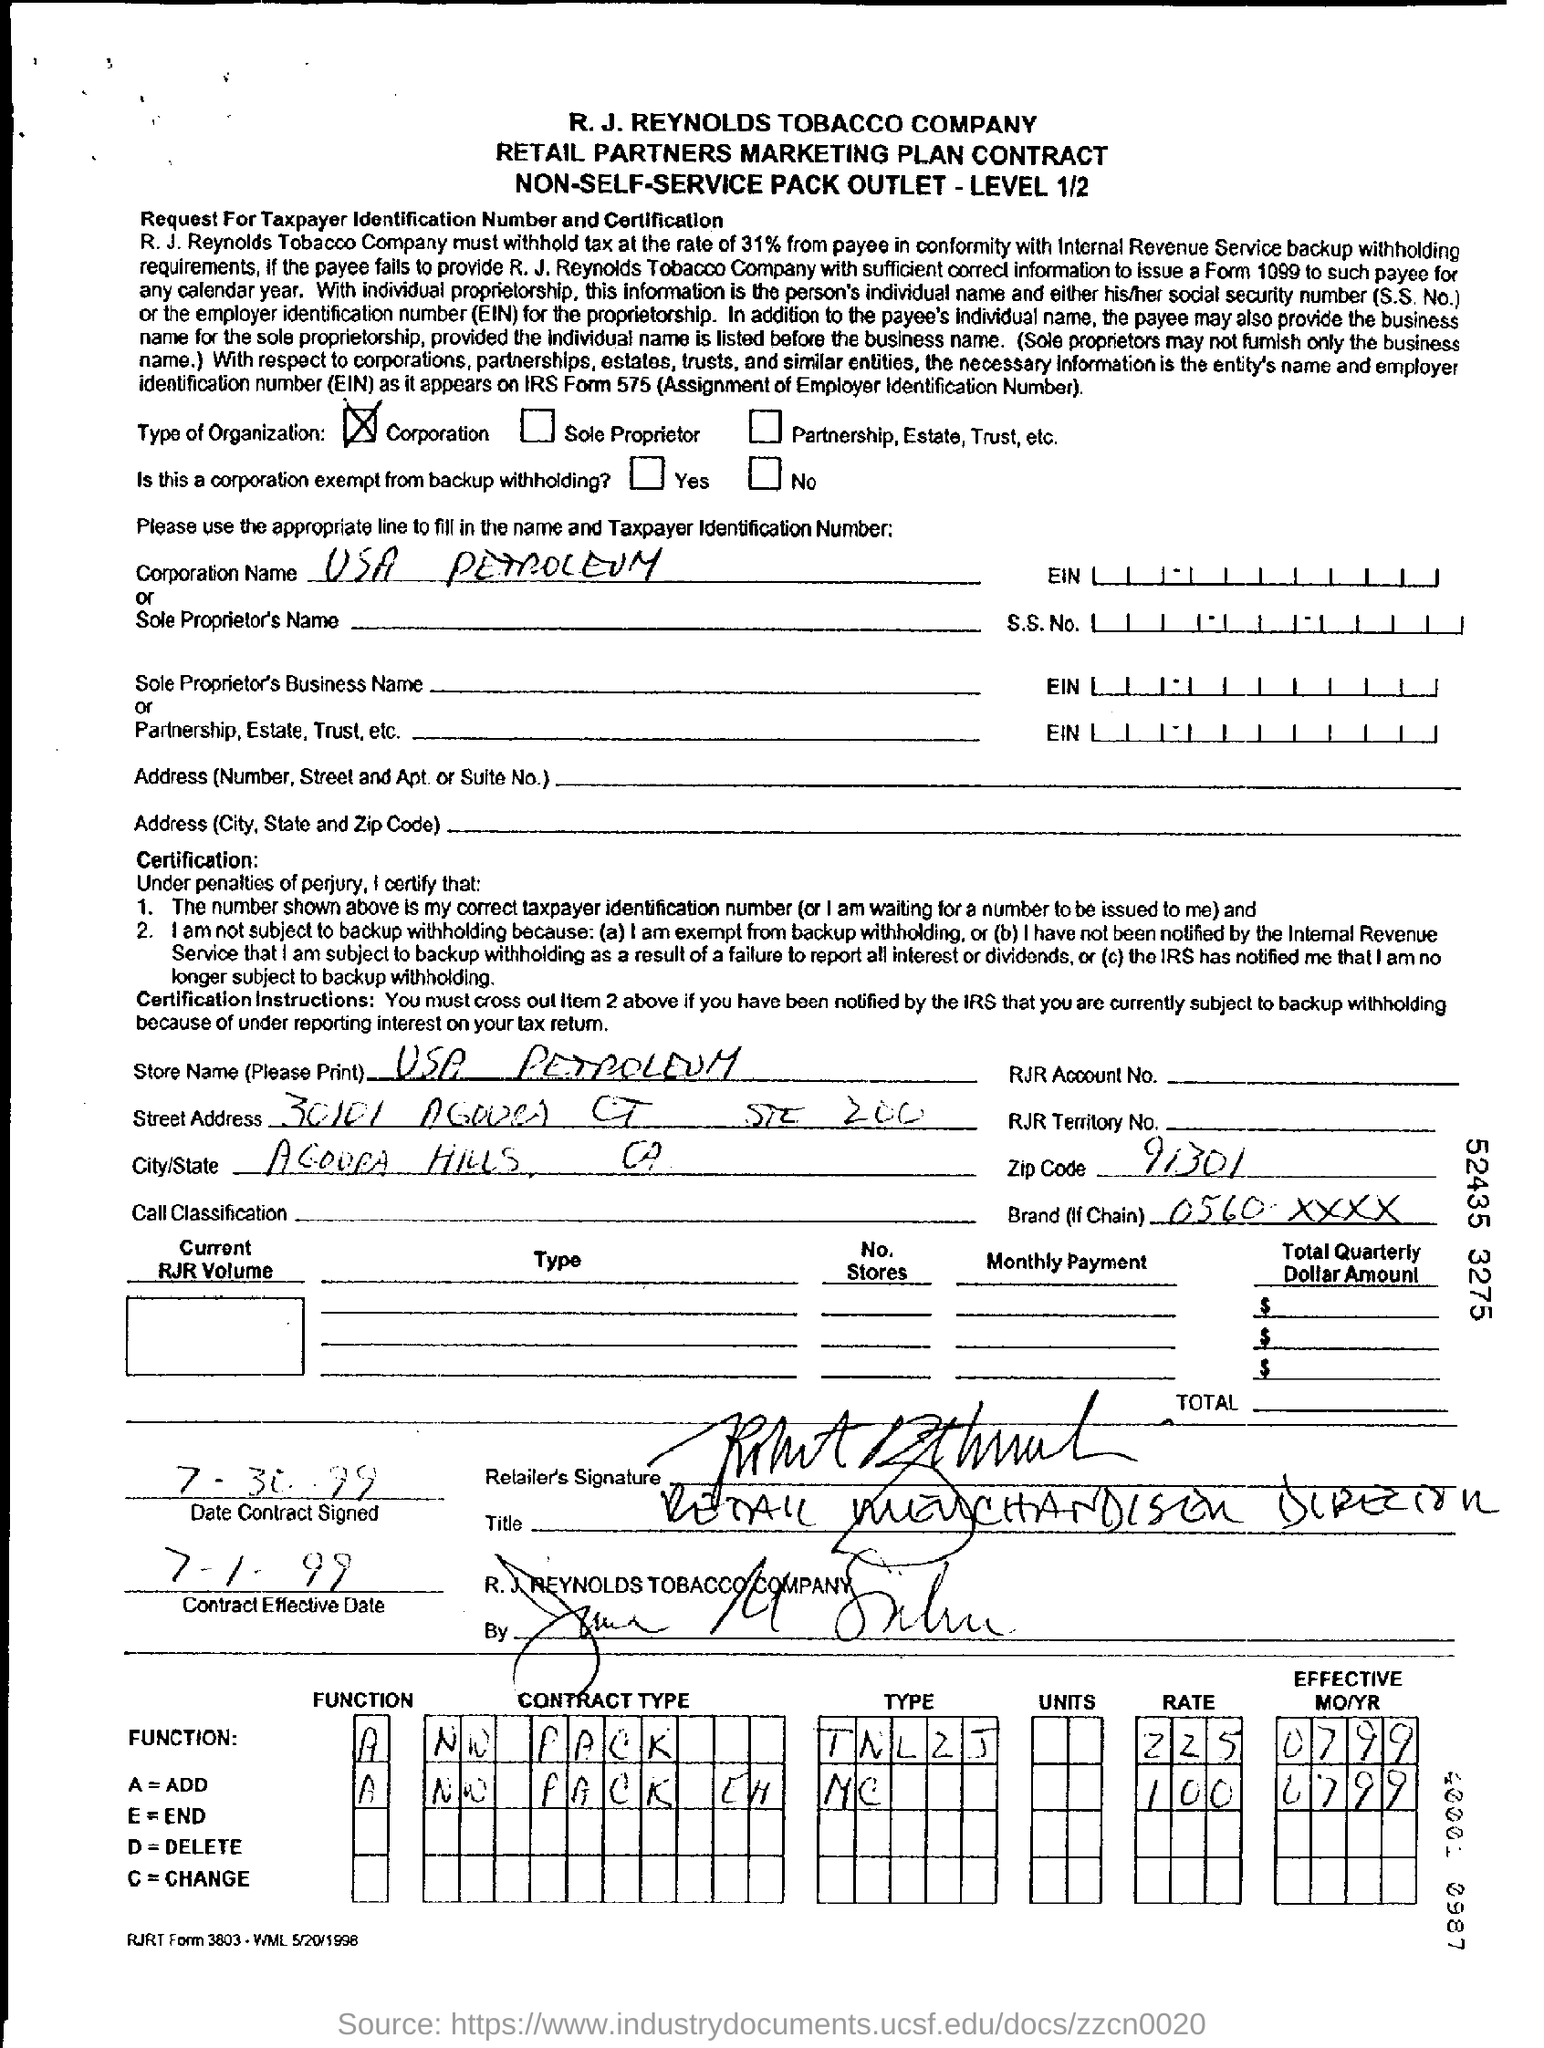What is the store name given in the contract form?
Your answer should be very brief. USA PETROLEUM. What is the contract effective date as per the document?
Give a very brief answer. 7-1-99. What is the zip code mentioned in the contract form?
Keep it short and to the point. 91301. 